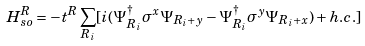<formula> <loc_0><loc_0><loc_500><loc_500>H _ { s o } ^ { R } = - t ^ { R } \sum _ { R _ { i } } [ i ( \Psi _ { R _ { i } } ^ { \dag } \sigma ^ { x } \Psi _ { R _ { i } + y } - \Psi _ { R _ { i } } ^ { \dag } \sigma ^ { y } \Psi _ { R _ { i } + x } ) + h . c . ]</formula> 